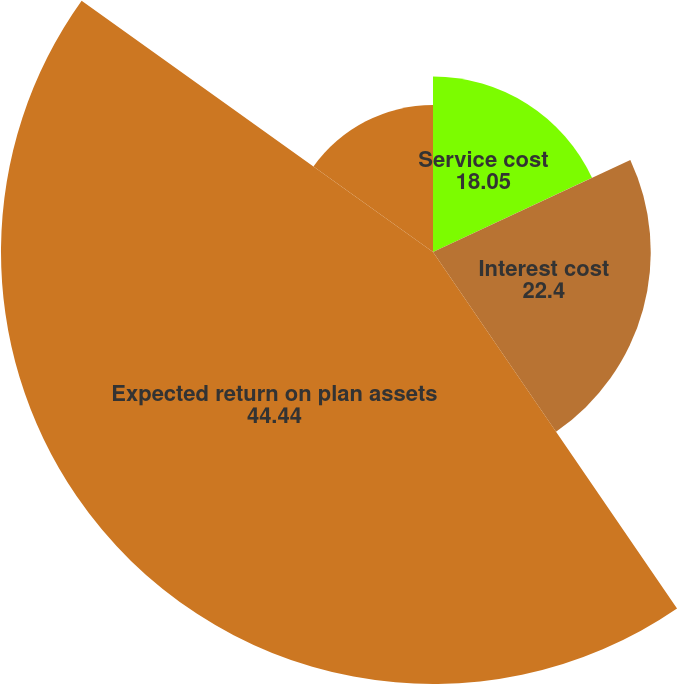<chart> <loc_0><loc_0><loc_500><loc_500><pie_chart><fcel>Service cost<fcel>Interest cost<fcel>Expected return on plan assets<fcel>Amortization<nl><fcel>18.05%<fcel>22.4%<fcel>44.44%<fcel>15.12%<nl></chart> 